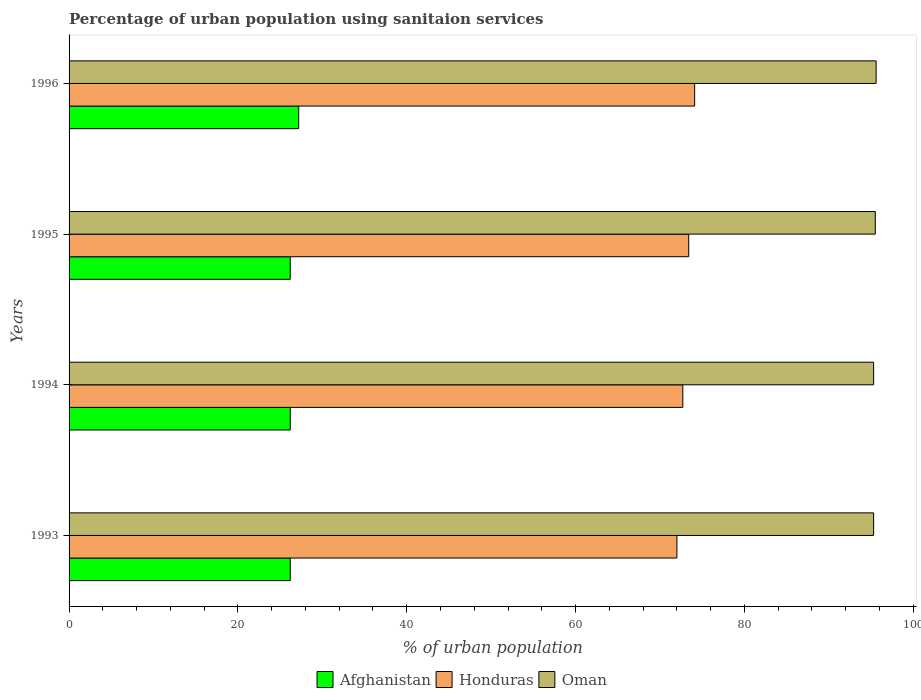How many different coloured bars are there?
Keep it short and to the point. 3. How many bars are there on the 1st tick from the top?
Give a very brief answer. 3. How many bars are there on the 4th tick from the bottom?
Offer a terse response. 3. What is the label of the 4th group of bars from the top?
Provide a succinct answer. 1993. What is the percentage of urban population using sanitaion services in Afghanistan in 1994?
Your answer should be very brief. 26.2. Across all years, what is the maximum percentage of urban population using sanitaion services in Afghanistan?
Offer a very short reply. 27.2. Across all years, what is the minimum percentage of urban population using sanitaion services in Oman?
Offer a very short reply. 95.3. In which year was the percentage of urban population using sanitaion services in Honduras maximum?
Provide a short and direct response. 1996. What is the total percentage of urban population using sanitaion services in Oman in the graph?
Your answer should be compact. 381.7. What is the difference between the percentage of urban population using sanitaion services in Oman in 1994 and that in 1995?
Your answer should be very brief. -0.2. What is the difference between the percentage of urban population using sanitaion services in Oman in 1994 and the percentage of urban population using sanitaion services in Honduras in 1996?
Provide a succinct answer. 21.2. What is the average percentage of urban population using sanitaion services in Honduras per year?
Provide a short and direct response. 73.05. In the year 1995, what is the difference between the percentage of urban population using sanitaion services in Oman and percentage of urban population using sanitaion services in Afghanistan?
Offer a terse response. 69.3. In how many years, is the percentage of urban population using sanitaion services in Oman greater than 40 %?
Provide a succinct answer. 4. What is the ratio of the percentage of urban population using sanitaion services in Honduras in 1993 to that in 1995?
Provide a succinct answer. 0.98. Is the difference between the percentage of urban population using sanitaion services in Oman in 1994 and 1996 greater than the difference between the percentage of urban population using sanitaion services in Afghanistan in 1994 and 1996?
Keep it short and to the point. Yes. What is the difference between the highest and the lowest percentage of urban population using sanitaion services in Honduras?
Provide a short and direct response. 2.1. What does the 2nd bar from the top in 1994 represents?
Your answer should be compact. Honduras. What does the 1st bar from the bottom in 1996 represents?
Ensure brevity in your answer.  Afghanistan. Is it the case that in every year, the sum of the percentage of urban population using sanitaion services in Honduras and percentage of urban population using sanitaion services in Oman is greater than the percentage of urban population using sanitaion services in Afghanistan?
Give a very brief answer. Yes. Are all the bars in the graph horizontal?
Give a very brief answer. Yes. Are the values on the major ticks of X-axis written in scientific E-notation?
Offer a terse response. No. Does the graph contain any zero values?
Offer a terse response. No. How many legend labels are there?
Your response must be concise. 3. What is the title of the graph?
Offer a terse response. Percentage of urban population using sanitaion services. What is the label or title of the X-axis?
Provide a short and direct response. % of urban population. What is the % of urban population in Afghanistan in 1993?
Offer a terse response. 26.2. What is the % of urban population of Honduras in 1993?
Your response must be concise. 72. What is the % of urban population in Oman in 1993?
Your response must be concise. 95.3. What is the % of urban population of Afghanistan in 1994?
Your answer should be compact. 26.2. What is the % of urban population of Honduras in 1994?
Give a very brief answer. 72.7. What is the % of urban population in Oman in 1994?
Make the answer very short. 95.3. What is the % of urban population in Afghanistan in 1995?
Make the answer very short. 26.2. What is the % of urban population in Honduras in 1995?
Ensure brevity in your answer.  73.4. What is the % of urban population in Oman in 1995?
Provide a short and direct response. 95.5. What is the % of urban population in Afghanistan in 1996?
Offer a terse response. 27.2. What is the % of urban population of Honduras in 1996?
Your answer should be compact. 74.1. What is the % of urban population of Oman in 1996?
Make the answer very short. 95.6. Across all years, what is the maximum % of urban population of Afghanistan?
Your response must be concise. 27.2. Across all years, what is the maximum % of urban population in Honduras?
Offer a terse response. 74.1. Across all years, what is the maximum % of urban population of Oman?
Your answer should be very brief. 95.6. Across all years, what is the minimum % of urban population in Afghanistan?
Provide a short and direct response. 26.2. Across all years, what is the minimum % of urban population in Honduras?
Keep it short and to the point. 72. Across all years, what is the minimum % of urban population of Oman?
Provide a short and direct response. 95.3. What is the total % of urban population of Afghanistan in the graph?
Ensure brevity in your answer.  105.8. What is the total % of urban population of Honduras in the graph?
Your response must be concise. 292.2. What is the total % of urban population of Oman in the graph?
Give a very brief answer. 381.7. What is the difference between the % of urban population of Afghanistan in 1993 and that in 1994?
Your answer should be very brief. 0. What is the difference between the % of urban population in Honduras in 1993 and that in 1994?
Your answer should be very brief. -0.7. What is the difference between the % of urban population of Afghanistan in 1993 and that in 1995?
Offer a terse response. 0. What is the difference between the % of urban population in Oman in 1993 and that in 1995?
Give a very brief answer. -0.2. What is the difference between the % of urban population in Honduras in 1993 and that in 1996?
Ensure brevity in your answer.  -2.1. What is the difference between the % of urban population of Afghanistan in 1994 and that in 1995?
Provide a succinct answer. 0. What is the difference between the % of urban population of Honduras in 1994 and that in 1995?
Give a very brief answer. -0.7. What is the difference between the % of urban population of Oman in 1994 and that in 1995?
Your response must be concise. -0.2. What is the difference between the % of urban population in Afghanistan in 1993 and the % of urban population in Honduras in 1994?
Offer a very short reply. -46.5. What is the difference between the % of urban population in Afghanistan in 1993 and the % of urban population in Oman in 1994?
Offer a very short reply. -69.1. What is the difference between the % of urban population of Honduras in 1993 and the % of urban population of Oman in 1994?
Offer a very short reply. -23.3. What is the difference between the % of urban population of Afghanistan in 1993 and the % of urban population of Honduras in 1995?
Give a very brief answer. -47.2. What is the difference between the % of urban population in Afghanistan in 1993 and the % of urban population in Oman in 1995?
Ensure brevity in your answer.  -69.3. What is the difference between the % of urban population of Honduras in 1993 and the % of urban population of Oman in 1995?
Make the answer very short. -23.5. What is the difference between the % of urban population of Afghanistan in 1993 and the % of urban population of Honduras in 1996?
Ensure brevity in your answer.  -47.9. What is the difference between the % of urban population in Afghanistan in 1993 and the % of urban population in Oman in 1996?
Your answer should be very brief. -69.4. What is the difference between the % of urban population in Honduras in 1993 and the % of urban population in Oman in 1996?
Offer a terse response. -23.6. What is the difference between the % of urban population in Afghanistan in 1994 and the % of urban population in Honduras in 1995?
Provide a succinct answer. -47.2. What is the difference between the % of urban population in Afghanistan in 1994 and the % of urban population in Oman in 1995?
Your answer should be very brief. -69.3. What is the difference between the % of urban population in Honduras in 1994 and the % of urban population in Oman in 1995?
Ensure brevity in your answer.  -22.8. What is the difference between the % of urban population in Afghanistan in 1994 and the % of urban population in Honduras in 1996?
Ensure brevity in your answer.  -47.9. What is the difference between the % of urban population in Afghanistan in 1994 and the % of urban population in Oman in 1996?
Keep it short and to the point. -69.4. What is the difference between the % of urban population in Honduras in 1994 and the % of urban population in Oman in 1996?
Your answer should be compact. -22.9. What is the difference between the % of urban population in Afghanistan in 1995 and the % of urban population in Honduras in 1996?
Offer a very short reply. -47.9. What is the difference between the % of urban population in Afghanistan in 1995 and the % of urban population in Oman in 1996?
Ensure brevity in your answer.  -69.4. What is the difference between the % of urban population in Honduras in 1995 and the % of urban population in Oman in 1996?
Provide a short and direct response. -22.2. What is the average % of urban population of Afghanistan per year?
Make the answer very short. 26.45. What is the average % of urban population in Honduras per year?
Keep it short and to the point. 73.05. What is the average % of urban population of Oman per year?
Your answer should be compact. 95.42. In the year 1993, what is the difference between the % of urban population of Afghanistan and % of urban population of Honduras?
Provide a succinct answer. -45.8. In the year 1993, what is the difference between the % of urban population in Afghanistan and % of urban population in Oman?
Make the answer very short. -69.1. In the year 1993, what is the difference between the % of urban population of Honduras and % of urban population of Oman?
Offer a terse response. -23.3. In the year 1994, what is the difference between the % of urban population of Afghanistan and % of urban population of Honduras?
Keep it short and to the point. -46.5. In the year 1994, what is the difference between the % of urban population of Afghanistan and % of urban population of Oman?
Give a very brief answer. -69.1. In the year 1994, what is the difference between the % of urban population of Honduras and % of urban population of Oman?
Ensure brevity in your answer.  -22.6. In the year 1995, what is the difference between the % of urban population of Afghanistan and % of urban population of Honduras?
Your answer should be very brief. -47.2. In the year 1995, what is the difference between the % of urban population of Afghanistan and % of urban population of Oman?
Your response must be concise. -69.3. In the year 1995, what is the difference between the % of urban population in Honduras and % of urban population in Oman?
Ensure brevity in your answer.  -22.1. In the year 1996, what is the difference between the % of urban population of Afghanistan and % of urban population of Honduras?
Provide a short and direct response. -46.9. In the year 1996, what is the difference between the % of urban population of Afghanistan and % of urban population of Oman?
Ensure brevity in your answer.  -68.4. In the year 1996, what is the difference between the % of urban population in Honduras and % of urban population in Oman?
Provide a short and direct response. -21.5. What is the ratio of the % of urban population in Afghanistan in 1993 to that in 1995?
Make the answer very short. 1. What is the ratio of the % of urban population of Honduras in 1993 to that in 1995?
Offer a very short reply. 0.98. What is the ratio of the % of urban population in Oman in 1993 to that in 1995?
Give a very brief answer. 1. What is the ratio of the % of urban population of Afghanistan in 1993 to that in 1996?
Provide a short and direct response. 0.96. What is the ratio of the % of urban population of Honduras in 1993 to that in 1996?
Your answer should be compact. 0.97. What is the ratio of the % of urban population of Oman in 1993 to that in 1996?
Make the answer very short. 1. What is the ratio of the % of urban population of Oman in 1994 to that in 1995?
Give a very brief answer. 1. What is the ratio of the % of urban population in Afghanistan in 1994 to that in 1996?
Give a very brief answer. 0.96. What is the ratio of the % of urban population of Honduras in 1994 to that in 1996?
Offer a terse response. 0.98. What is the ratio of the % of urban population in Oman in 1994 to that in 1996?
Offer a terse response. 1. What is the ratio of the % of urban population of Afghanistan in 1995 to that in 1996?
Make the answer very short. 0.96. What is the ratio of the % of urban population in Honduras in 1995 to that in 1996?
Make the answer very short. 0.99. What is the difference between the highest and the second highest % of urban population of Oman?
Keep it short and to the point. 0.1. What is the difference between the highest and the lowest % of urban population in Oman?
Give a very brief answer. 0.3. 